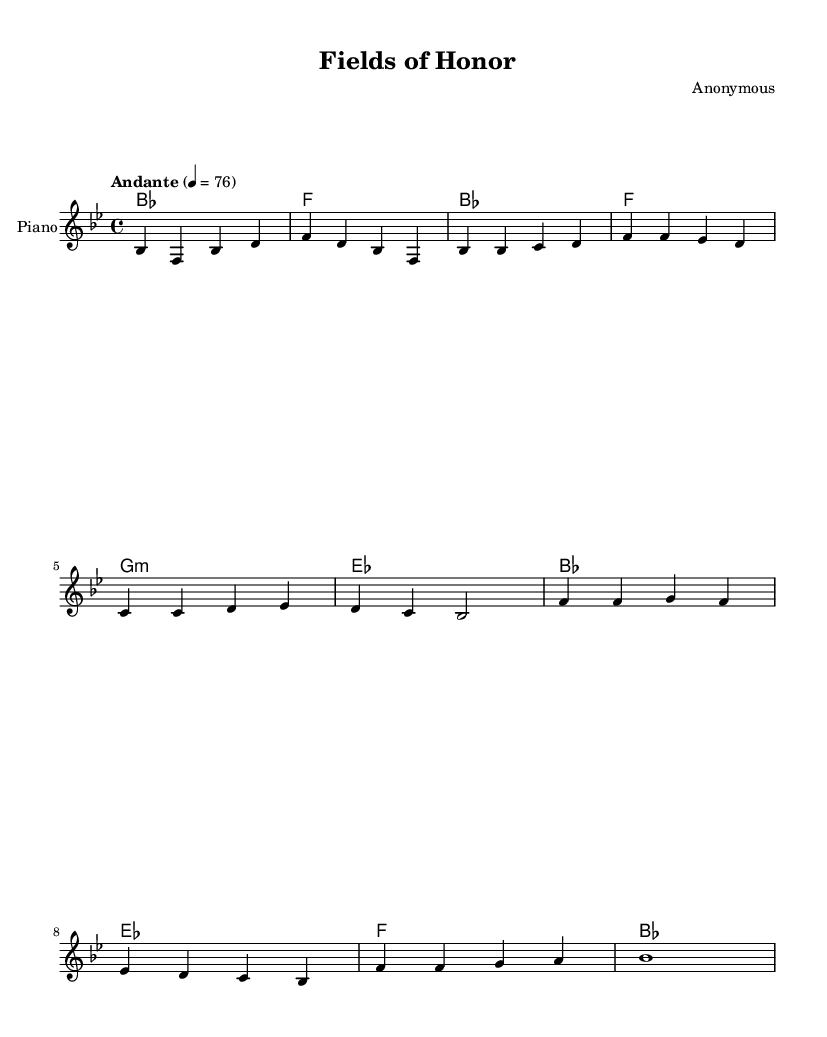What is the key signature of this music? The key signature is B flat major, which has two flats indicated by the placement of the flats on the staff.
Answer: B flat major What is the time signature of this music? The time signature, indicated at the beginning of the score, is 4/4, representing four beats in a measure.
Answer: 4/4 What is the tempo marking of this piece? The tempo marking "Andante" indicates a moderately slow tempo, and the metronome marking of 76 means there are 76 beats per minute.
Answer: Andante How many lines are in the chorus? The chorus consists of four lines, each detailing a specific emotional tribute to fallen heroes, which can be counted in the lyrics section.
Answer: Four Which section follows the verse in this piece? The chorus is the section that directly follows the verse, as indicated in the structure of the score.
Answer: Chorus What is the function of the chorus in this composition? The chorus serves as the refrain by summarizing the main theme of bravery and remembrance, capturing the essence of the patriotic anthem.
Answer: Refrain How many measures are in the verse? The verse consists of four measures as represented by the grouping of note symbols in that section of the score.
Answer: Four 